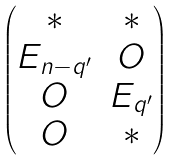<formula> <loc_0><loc_0><loc_500><loc_500>\begin{pmatrix} \ast & \ast \\ E _ { n - q ^ { \prime } } & O \\ O & E _ { q ^ { \prime } } \\ O & \ast \end{pmatrix}</formula> 